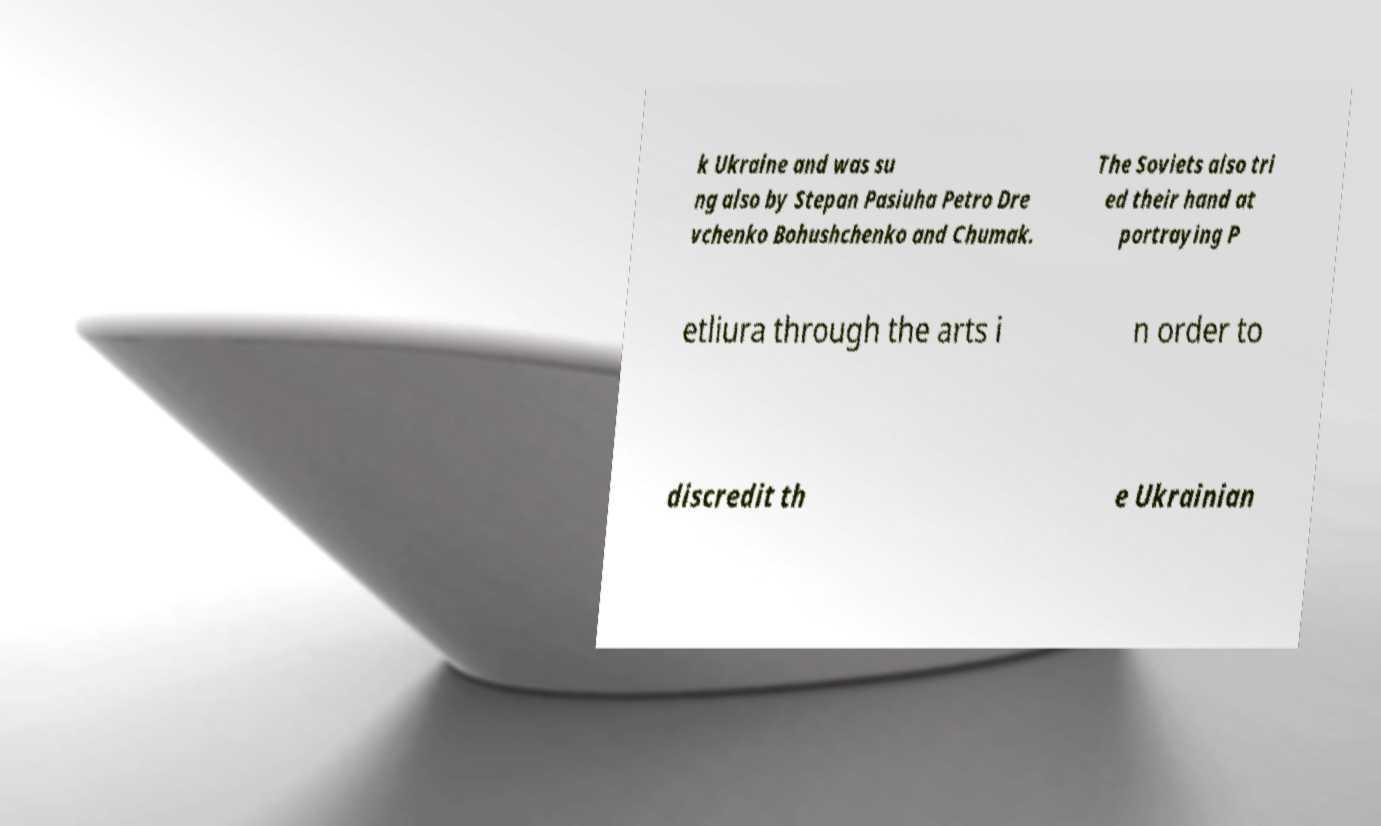I need the written content from this picture converted into text. Can you do that? k Ukraine and was su ng also by Stepan Pasiuha Petro Dre vchenko Bohushchenko and Chumak. The Soviets also tri ed their hand at portraying P etliura through the arts i n order to discredit th e Ukrainian 